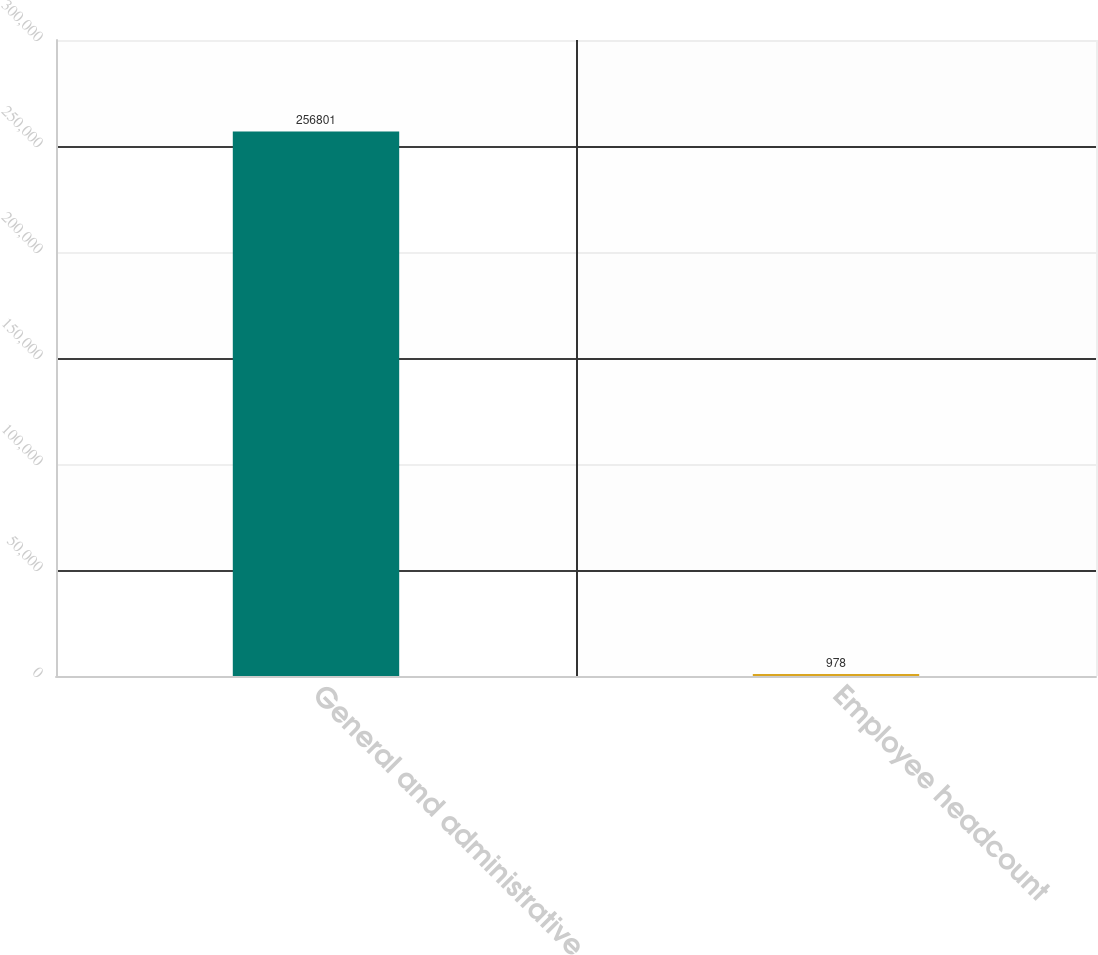Convert chart to OTSL. <chart><loc_0><loc_0><loc_500><loc_500><bar_chart><fcel>General and administrative<fcel>Employee headcount<nl><fcel>256801<fcel>978<nl></chart> 